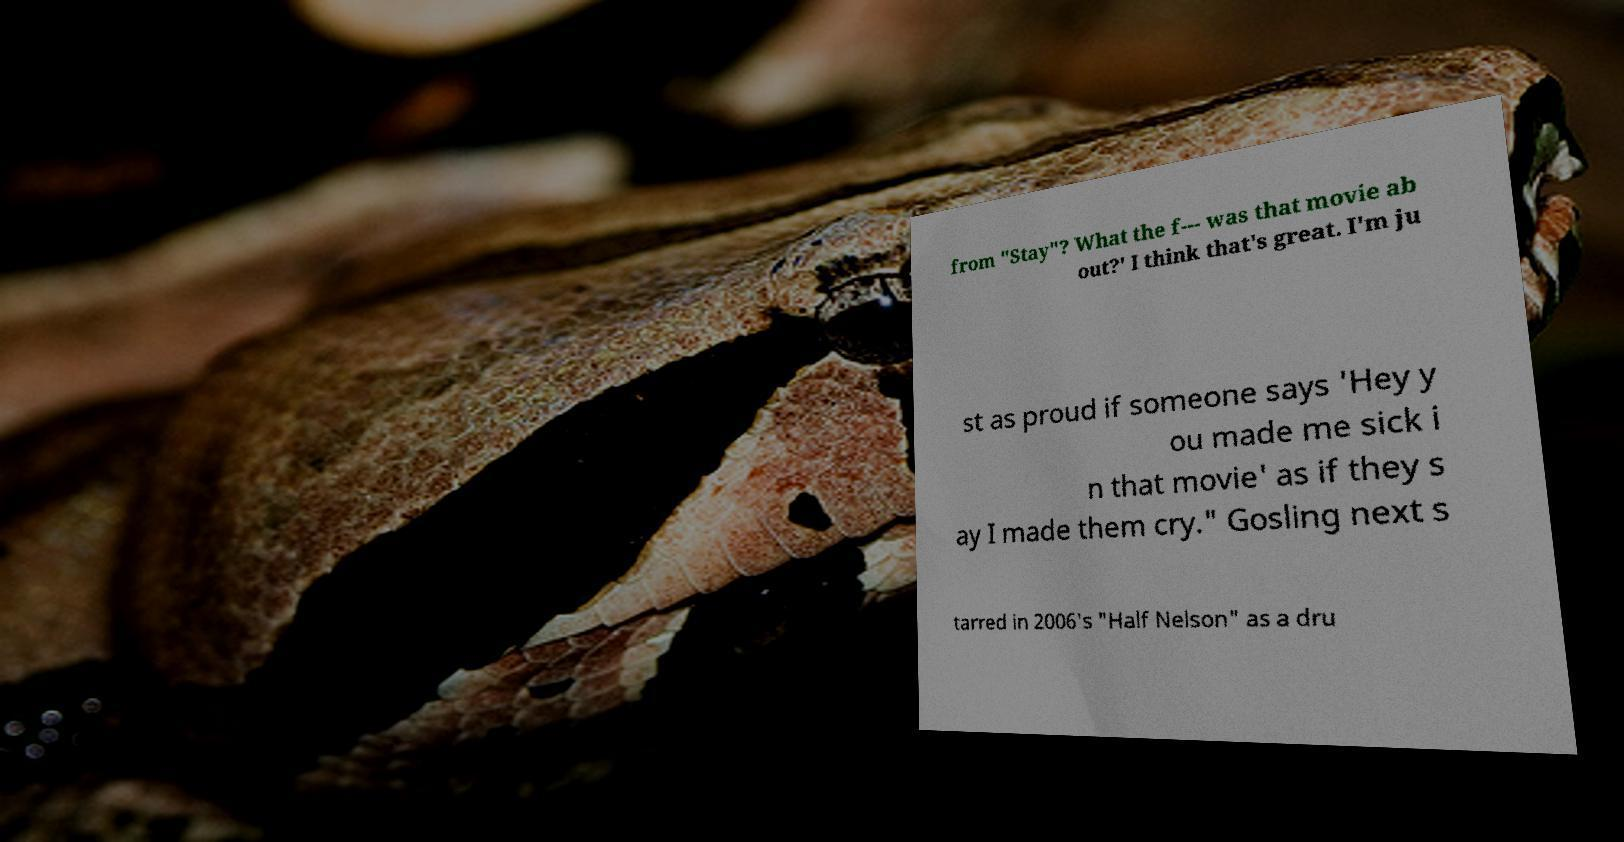What messages or text are displayed in this image? I need them in a readable, typed format. from "Stay"? What the f--- was that movie ab out?' I think that's great. I'm ju st as proud if someone says 'Hey y ou made me sick i n that movie' as if they s ay I made them cry." Gosling next s tarred in 2006's "Half Nelson" as a dru 